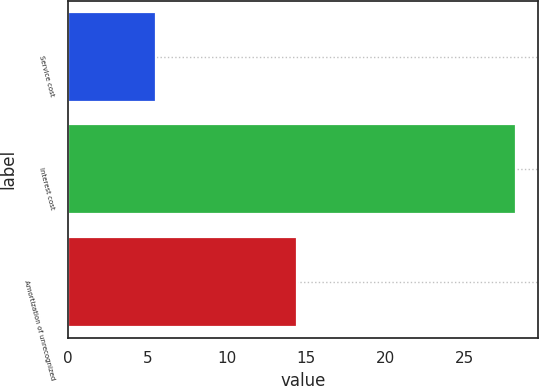<chart> <loc_0><loc_0><loc_500><loc_500><bar_chart><fcel>Service cost<fcel>Interest cost<fcel>Amortization of unrecognized<nl><fcel>5.5<fcel>28.2<fcel>14.4<nl></chart> 